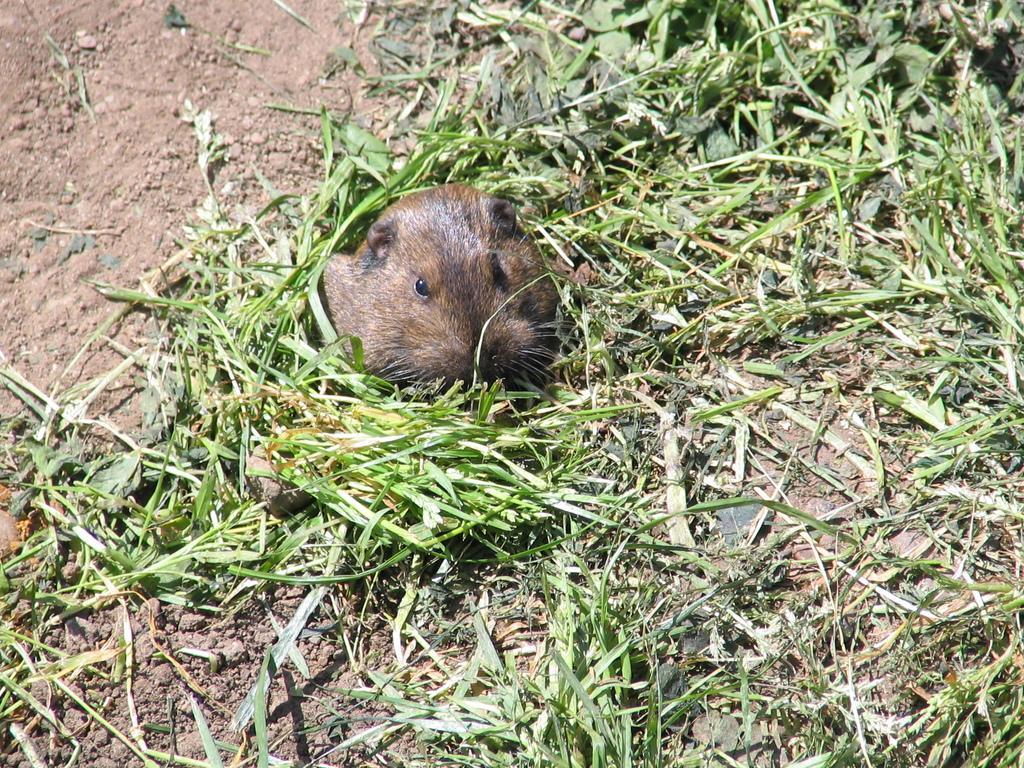How would you summarize this image in a sentence or two? In the image we can see there is a rat which is standing on the ground and the ground is covered with grass and mud. 